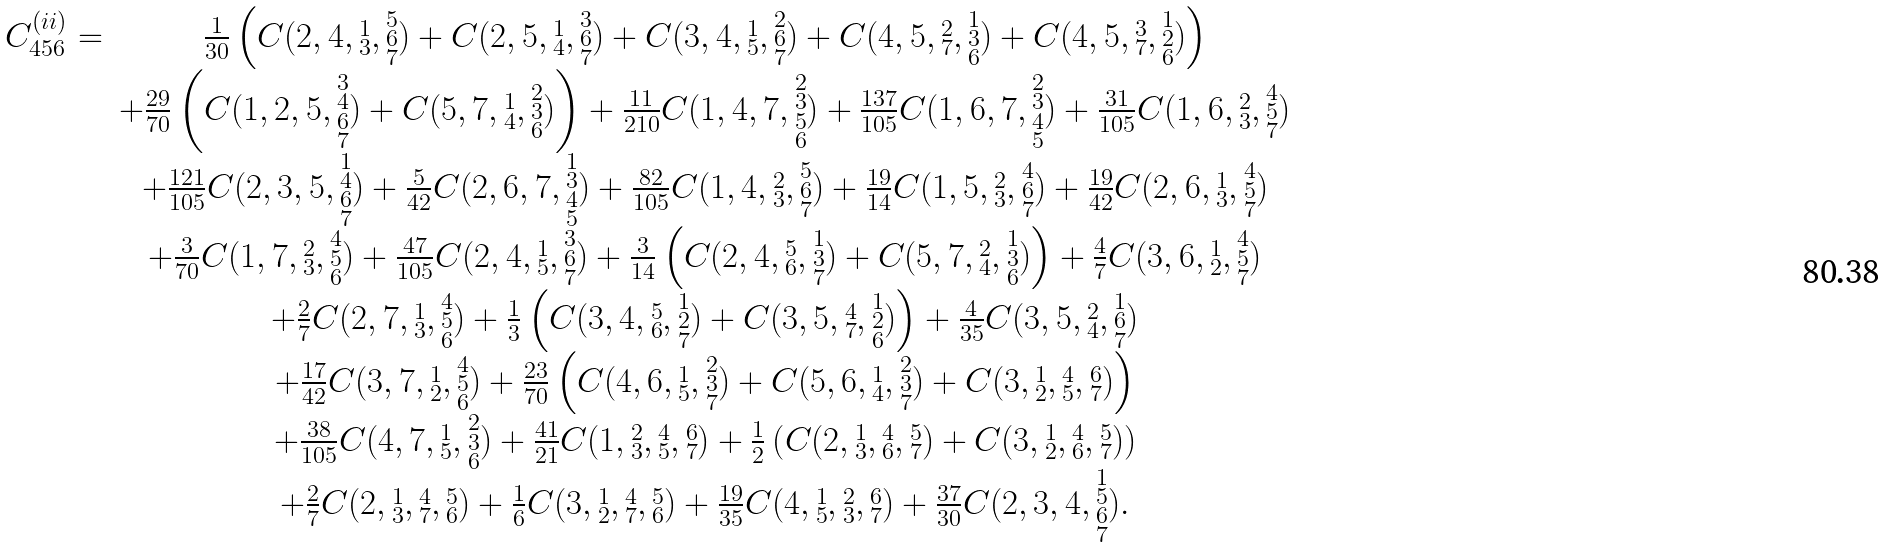Convert formula to latex. <formula><loc_0><loc_0><loc_500><loc_500>\begin{array} { r c } C ^ { ( i i ) } _ { 4 5 6 } = & \frac { 1 } { 3 0 } \left ( C ( 2 , 4 , \substack { 1 \\ 3 } , \substack { 5 \\ 6 \\ 7 } ) + C ( 2 , 5 , \substack { 1 \\ 4 } , \substack { 3 \\ 6 \\ 7 } ) + C ( 3 , 4 , \substack { 1 \\ 5 } , \substack { 2 \\ 6 \\ 7 } ) + C ( 4 , 5 , \substack { 2 \\ 7 } , \substack { 1 \\ 3 \\ 6 } ) + C ( 4 , 5 , \substack { 3 \\ 7 } , \substack { 1 \\ 2 \\ 6 } ) \right ) \\ & + \frac { 2 9 } { 7 0 } \left ( C ( 1 , 2 , 5 , \substack { 3 \\ 4 \\ 6 \\ 7 } ) + C ( 5 , 7 , \substack { 1 \\ 4 } , \substack { 2 \\ 3 \\ 6 } ) \right ) + \frac { 1 1 } { 2 1 0 } C ( 1 , 4 , 7 , \substack { 2 \\ 3 \\ 5 \\ 6 } ) + \frac { 1 3 7 } { 1 0 5 } C ( 1 , 6 , 7 , \substack { 2 \\ 3 \\ 4 \\ 5 } ) + \frac { 3 1 } { 1 0 5 } C ( 1 , 6 , \substack { 2 \\ 3 } , \substack { 4 \\ 5 \\ 7 } ) \\ & + \frac { 1 2 1 } { 1 0 5 } C ( 2 , 3 , 5 , \substack { 1 \\ 4 \\ 6 \\ 7 } ) + \frac { 5 } { 4 2 } C ( 2 , 6 , 7 , \substack { 1 \\ 3 \\ 4 \\ 5 } ) + \frac { 8 2 } { 1 0 5 } C ( 1 , 4 , \substack { 2 \\ 3 } , \substack { 5 \\ 6 \\ 7 } ) + \frac { 1 9 } { 1 4 } C ( 1 , 5 , \substack { 2 \\ 3 } , \substack { 4 \\ 6 \\ 7 } ) + \frac { 1 9 } { 4 2 } C ( 2 , 6 , \substack { 1 \\ 3 } , \substack { 4 \\ 5 \\ 7 } ) \\ & + \frac { 3 } { 7 0 } C ( 1 , 7 , \substack { 2 \\ 3 } , \substack { 4 \\ 5 \\ 6 } ) + \frac { 4 7 } { 1 0 5 } C ( 2 , 4 , \substack { 1 \\ 5 } , \substack { 3 \\ 6 \\ 7 } ) + \frac { 3 } { 1 4 } \left ( C ( 2 , 4 , \substack { 5 \\ 6 } , \substack { 1 \\ 3 \\ 7 } ) + C ( 5 , 7 , \substack { 2 \\ 4 } , \substack { 1 \\ 3 \\ 6 } ) \right ) + \frac { 4 } { 7 } C ( 3 , 6 , \substack { 1 \\ 2 } , \substack { 4 \\ 5 \\ 7 } ) \\ & + \frac { 2 } { 7 } C ( 2 , 7 , \substack { 1 \\ 3 } , \substack { 4 \\ 5 \\ 6 } ) + \frac { 1 } { 3 } \left ( C ( 3 , 4 , \substack { 5 \\ 6 } , \substack { 1 \\ 2 \\ 7 } ) + C ( 3 , 5 , \substack { 4 \\ 7 } , \substack { 1 \\ 2 \\ 6 } ) \right ) + \frac { 4 } { 3 5 } C ( 3 , 5 , \substack { 2 \\ 4 } , \substack { 1 \\ 6 \\ 7 } ) \\ & + \frac { 1 7 } { 4 2 } C ( 3 , 7 , \substack { 1 \\ 2 } , \substack { 4 \\ 5 \\ 6 } ) + \frac { 2 3 } { 7 0 } \left ( C ( 4 , 6 , \substack { 1 \\ 5 } , \substack { 2 \\ 3 \\ 7 } ) + C ( 5 , 6 , \substack { 1 \\ 4 } , \substack { 2 \\ 3 \\ 7 } ) + C ( 3 , \substack { 1 \\ 2 } , \substack { 4 \\ 5 } , \substack { 6 \\ 7 } ) \right ) \\ & + \frac { 3 8 } { 1 0 5 } C ( 4 , 7 , \substack { 1 \\ 5 } , \substack { 2 \\ 3 \\ 6 } ) + \frac { 4 1 } { 2 1 } C ( 1 , \substack { 2 \\ 3 } , \substack { 4 \\ 5 } , \substack { 6 \\ 7 } ) + \frac { 1 } { 2 } \left ( C ( 2 , \substack { 1 \\ 3 } , \substack { 4 \\ 6 } , \substack { 5 \\ 7 } ) + C ( 3 , \substack { 1 \\ 2 } , \substack { 4 \\ 6 } , \substack { 5 \\ 7 } ) \right ) \\ & + \frac { 2 } { 7 } C ( 2 , \substack { 1 \\ 3 } , \substack { 4 \\ 7 } , \substack { 5 \\ 6 } ) + \frac { 1 } { 6 } C ( 3 , \substack { 1 \\ 2 } , \substack { 4 \\ 7 } , \substack { 5 \\ 6 } ) + \frac { 1 9 } { 3 5 } C ( 4 , \substack { 1 \\ 5 } , \substack { 2 \\ 3 } , \substack { 6 \\ 7 } ) + \frac { 3 7 } { 3 0 } C ( 2 , 3 , 4 , \substack { 1 \\ 5 \\ 6 \\ 7 } ) . \end{array}</formula> 